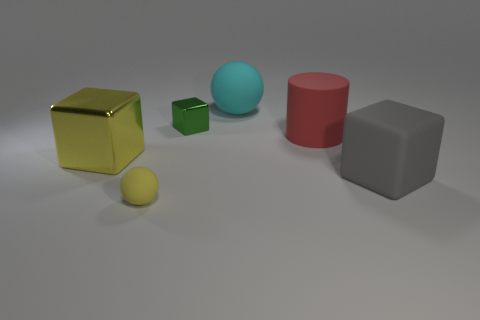Subtract all green shiny cubes. How many cubes are left? 2 Subtract 2 balls. How many balls are left? 0 Subtract all cylinders. How many objects are left? 5 Add 2 yellow metallic objects. How many objects exist? 8 Subtract all green cubes. How many cubes are left? 2 Subtract all tiny brown metal spheres. Subtract all red rubber cylinders. How many objects are left? 5 Add 5 small yellow things. How many small yellow things are left? 6 Add 5 yellow rubber spheres. How many yellow rubber spheres exist? 6 Subtract 1 yellow blocks. How many objects are left? 5 Subtract all gray cylinders. Subtract all red spheres. How many cylinders are left? 1 